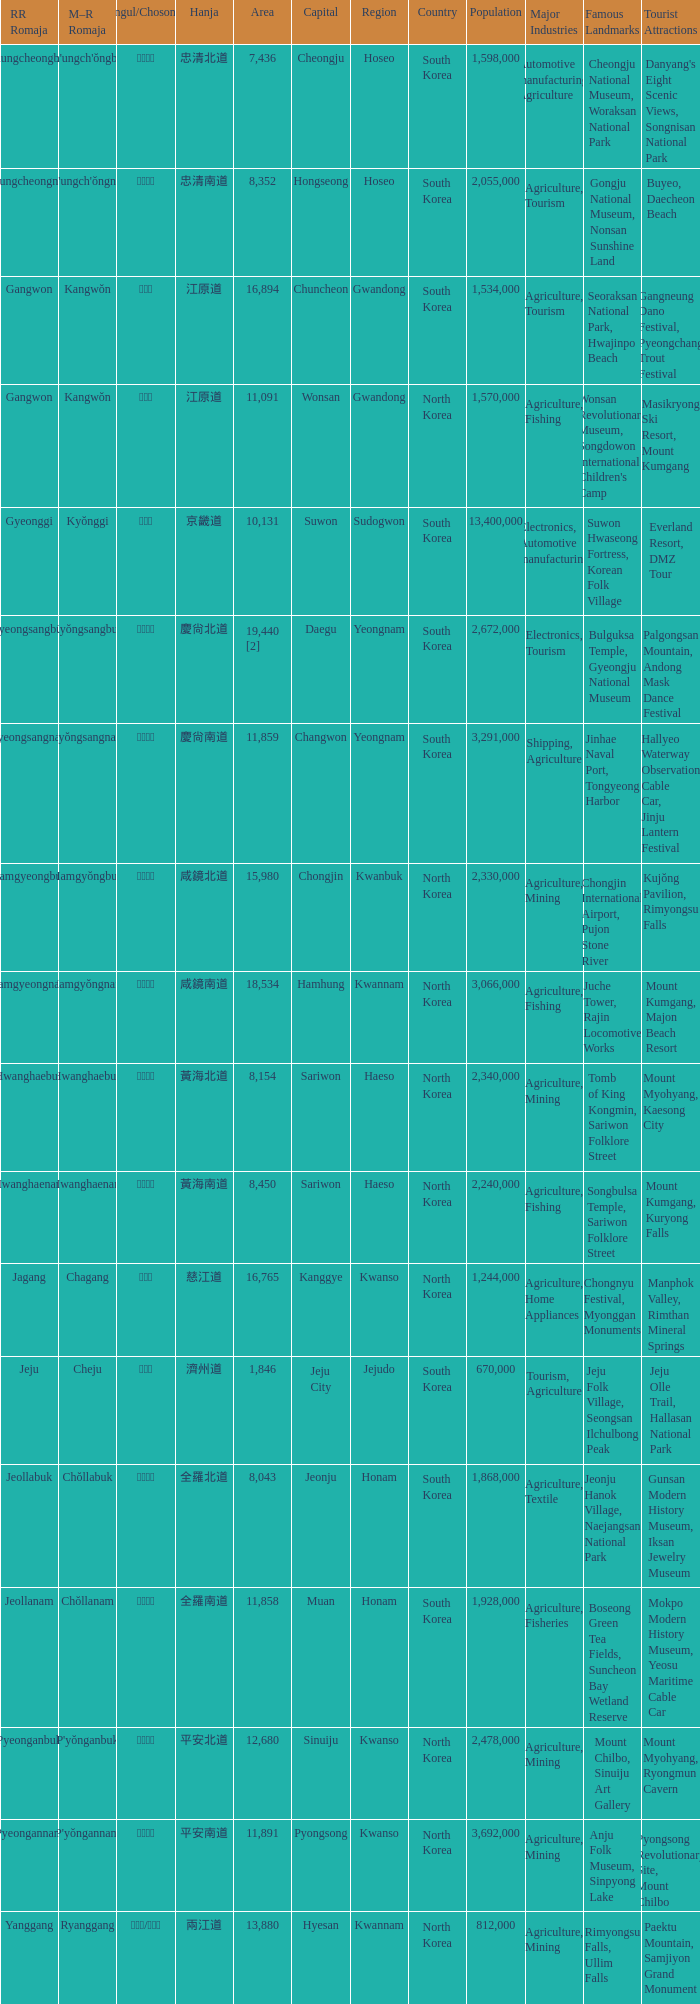Give me the full table as a dictionary. {'header': ['RR Romaja', 'M–R Romaja', 'Hangul/Chosongul', 'Hanja', 'Area', 'Capital', 'Region', 'Country', 'Population', 'Major Industries', 'Famous Landmarks', 'Tourist Attractions'], 'rows': [['Chungcheongbuk', "Ch'ungch'ŏngbuk", '충청북도', '忠清北道', '7,436', 'Cheongju', 'Hoseo', 'South Korea', '1,598,000', 'Automotive manufacturing, Agriculture', 'Cheongju National Museum, Woraksan National Park', "Danyang's Eight Scenic Views, Songnisan National Park"], ['Chungcheongnam', "Ch'ungch'ŏngnam", '충청남도', '忠清南道', '8,352', 'Hongseong', 'Hoseo', 'South Korea', '2,055,000', 'Agriculture, Tourism', 'Gongju National Museum, Nonsan Sunshine Land', 'Buyeo, Daecheon Beach'], ['Gangwon', 'Kangwŏn', '강원도', '江原道', '16,894', 'Chuncheon', 'Gwandong', 'South Korea', '1,534,000', 'Agriculture, Tourism', 'Seoraksan National Park, Hwajinpo Beach', 'Gangneung Dano Festival, Pyeongchang Trout Festival'], ['Gangwon', 'Kangwŏn', '강원도', '江原道', '11,091', 'Wonsan', 'Gwandong', 'North Korea', '1,570,000', 'Agriculture, Fishing', "Wonsan Revolutionary Museum, Songdowon International Children's Camp", 'Masikryong Ski Resort, Mount Kumgang'], ['Gyeonggi', 'Kyŏnggi', '경기도', '京畿道', '10,131', 'Suwon', 'Sudogwon', 'South Korea', '13,400,000', 'Electronics, Automotive manufacturing', 'Suwon Hwaseong Fortress, Korean Folk Village', 'Everland Resort, DMZ Tour'], ['Gyeongsangbuk', 'Kyŏngsangbuk', '경상북도', '慶尙北道', '19,440 [2]', 'Daegu', 'Yeongnam', 'South Korea', '2,672,000', 'Electronics, Tourism', 'Bulguksa Temple, Gyeongju National Museum', 'Palgongsan Mountain, Andong Mask Dance Festival'], ['Gyeongsangnam', 'Kyŏngsangnam', '경상남도', '慶尙南道', '11,859', 'Changwon', 'Yeongnam', 'South Korea', '3,291,000', 'Shipping, Agriculture', 'Jinhae Naval Port, Tongyeong Harbor', 'Hallyeo Waterway Observation Cable Car, Jinju Lantern Festival'], ['Hamgyeongbuk', 'Hamgyŏngbuk', '함경북도', '咸鏡北道', '15,980', 'Chongjin', 'Kwanbuk', 'North Korea', '2,330,000', 'Agriculture, Mining', 'Chongjin International Airport, Pujon Stone River', 'Kujŏng Pavilion, Rimyongsu Falls'], ['Hamgyeongnam', 'Hamgyŏngnam', '함경남도', '咸鏡南道', '18,534', 'Hamhung', 'Kwannam', 'North Korea', '3,066,000', 'Agriculture, Fishing', 'Juche Tower, Rajin Locomotive Works', 'Mount Kumgang, Majon Beach Resort'], ['Hwanghaebuk', 'Hwanghaebuk', '황해북도', '黃海北道', '8,154', 'Sariwon', 'Haeso', 'North Korea', '2,340,000', 'Agriculture, Mining', 'Tomb of King Kongmin, Sariwon Folklore Street', 'Mount Myohyang, Kaesong City'], ['Hwanghaenam', 'Hwanghaenam', '황해남도', '黃海南道', '8,450', 'Sariwon', 'Haeso', 'North Korea', '2,240,000', 'Agriculture, Fishing', 'Songbulsa Temple, Sariwon Folklore Street', 'Mount Kumgang, Kuryong Falls'], ['Jagang', 'Chagang', '자강도', '慈江道', '16,765', 'Kanggye', 'Kwanso', 'North Korea', '1,244,000', 'Agriculture, Home Appliances', 'Chongnyu Festival, Myonggan Monuments', 'Manphok Valley, Rimthan Mineral Springs'], ['Jeju', 'Cheju', '제주도', '濟州道', '1,846', 'Jeju City', 'Jejudo', 'South Korea', '670,000', 'Tourism, Agriculture', 'Jeju Folk Village, Seongsan Ilchulbong Peak', 'Jeju Olle Trail, Hallasan National Park'], ['Jeollabuk', 'Chŏllabuk', '전라북도', '全羅北道', '8,043', 'Jeonju', 'Honam', 'South Korea', '1,868,000', 'Agriculture, Textile', 'Jeonju Hanok Village, Naejangsan National Park', 'Gunsan Modern History Museum, Iksan Jewelry Museum'], ['Jeollanam', 'Chŏllanam', '전라남도', '全羅南道', '11,858', 'Muan', 'Honam', 'South Korea', '1,928,000', 'Agriculture, Fisheries', 'Boseong Green Tea Fields, Suncheon Bay Wetland Reserve', 'Mokpo Modern History Museum, Yeosu Maritime Cable Car'], ['Pyeonganbuk', "P'yŏnganbuk", '평안북도', '平安北道', '12,680', 'Sinuiju', 'Kwanso', 'North Korea', '2,478,000', 'Agriculture, Mining', 'Mount Chilbo, Sinuiju Art Gallery', 'Mount Myohyang, Ryongmun Cavern'], ['Pyeongannam', "P'yŏngannam", '평안남도', '平安南道', '11,891', 'Pyongsong', 'Kwanso', 'North Korea', '3,692,000', 'Agriculture, Mining', 'Anju Folk Museum, Sinpyong Lake', 'Pyongsong Revolutionary Site, Mount Chilbo'], ['Yanggang', 'Ryanggang', '량강도/양강도', '兩江道', '13,880', 'Hyesan', 'Kwannam', 'North Korea', '812,000', 'Agriculture, Mining', 'Rimyongsu Falls, Ullim Falls', 'Paektu Mountain, Samjiyon Grand Monument']]} What is the M-R Romaja for the province having a capital of Cheongju? Ch'ungch'ŏngbuk. 